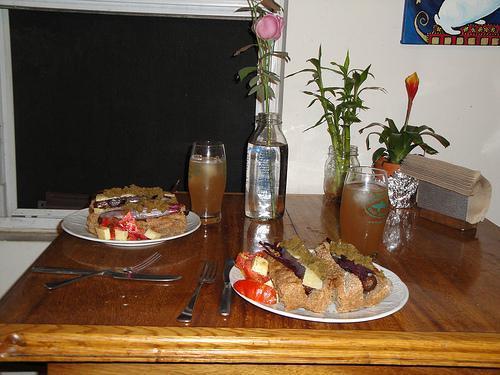How many plates are on the table?
Give a very brief answer. 2. How many plants are there?
Give a very brief answer. 3. 